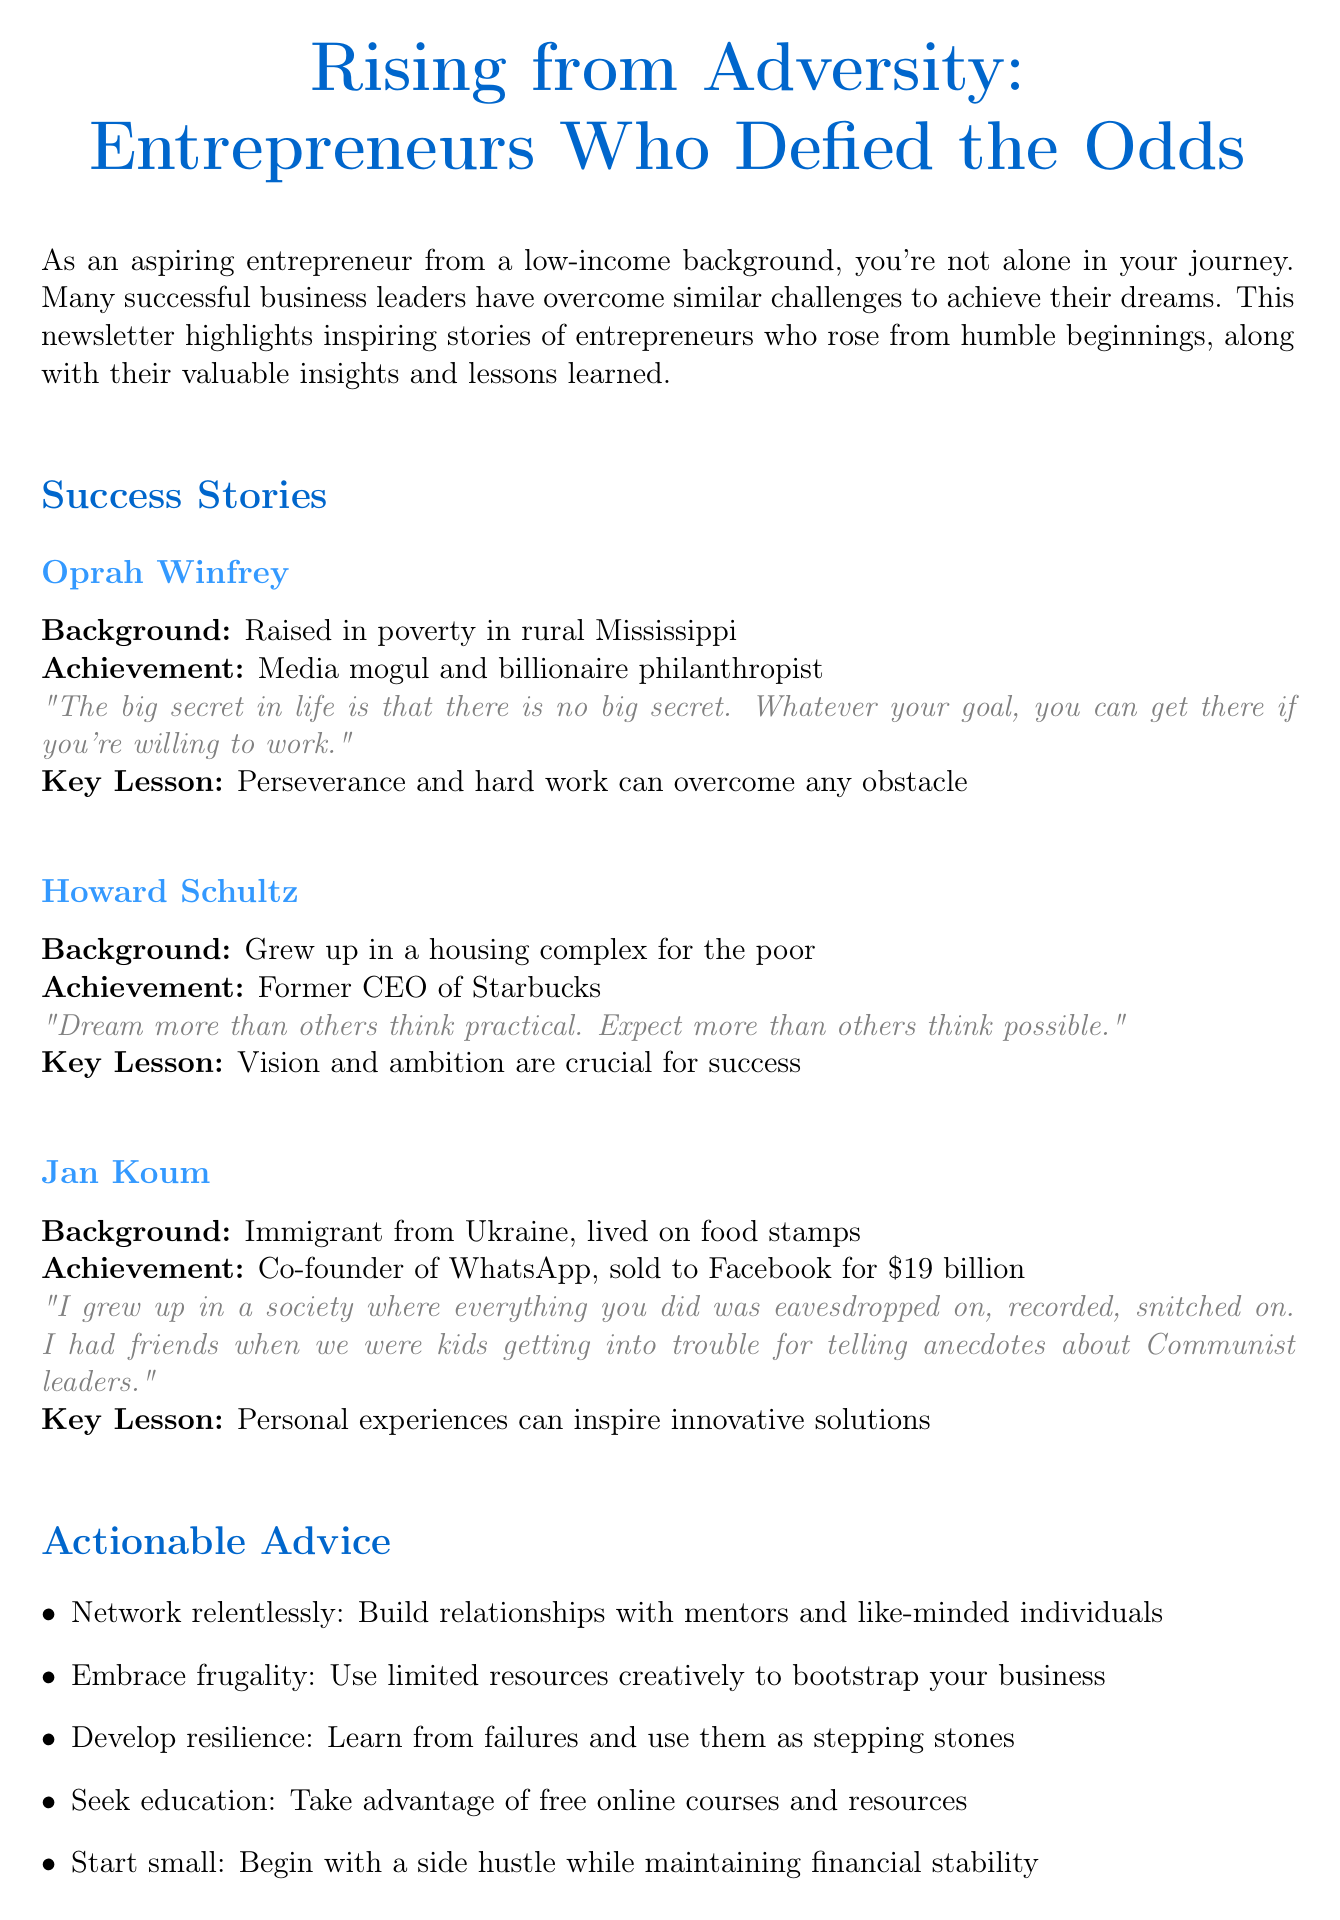What is the title of the newsletter? The title of the newsletter is stated at the beginning of the document.
Answer: Rising from Adversity: Entrepreneurs Who Defied the Odds Who is the co-founder of WhatsApp? The document mentions successful entrepreneurs and their achievements; Jan Koum is identified as the co-founder of WhatsApp.
Answer: Jan Koum What is Oprah Winfrey's key lesson? The key lessons learned by each entrepreneur are highlighted in the document; Oprah Winfrey's lesson is specifically mentioned.
Answer: Perseverance and hard work can overcome any obstacle Which free resource offers business counseling? The resource section lists various organizations that provide support for entrepreneurs; the Small Business Administration is one of them.
Answer: Small Business Administration (SBA) What does Howard Schultz say about dreaming? Each entrepreneur's quote is shared for inspiration; Howard Schultz emphasizes dreaming in his quote.
Answer: Dream more than others think practical. Expect more than others think possible What is one piece of actionable advice given? The document lists actionable advice for aspiring entrepreneurs; one of these pieces is highlighted.
Answer: Network relentlessly: Build relationships with mentors and like-minded individuals How much did WhatsApp sell for? The document specifies the achievement of Jan Koum, including the sale price of WhatsApp.
Answer: $19 billion What background did Jan Koum come from? Each entrepreneur's background is outlined in their story; Jan Koum's background specifically is mentioned.
Answer: Immigrant from Ukraine, lived on food stamps 